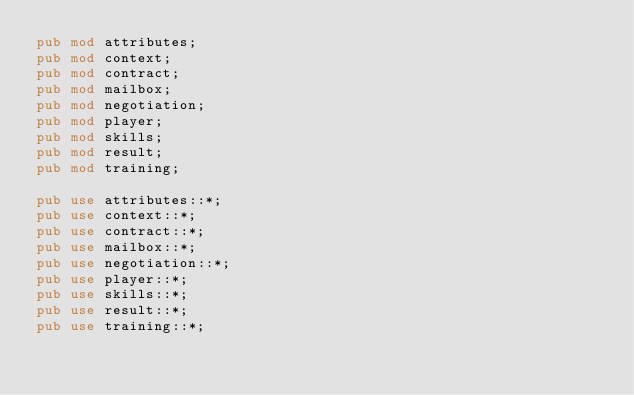Convert code to text. <code><loc_0><loc_0><loc_500><loc_500><_Rust_>pub mod attributes;
pub mod context;
pub mod contract;
pub mod mailbox;
pub mod negotiation;
pub mod player;
pub mod skills;
pub mod result;
pub mod training;

pub use attributes::*;
pub use context::*;
pub use contract::*;
pub use mailbox::*;
pub use negotiation::*;
pub use player::*;
pub use skills::*;
pub use result::*;
pub use training::*;
</code> 